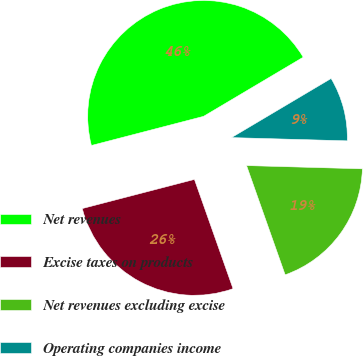<chart> <loc_0><loc_0><loc_500><loc_500><pie_chart><fcel>Net revenues<fcel>Excise taxes on products<fcel>Net revenues excluding excise<fcel>Operating companies income<nl><fcel>45.52%<fcel>26.36%<fcel>19.15%<fcel>8.97%<nl></chart> 